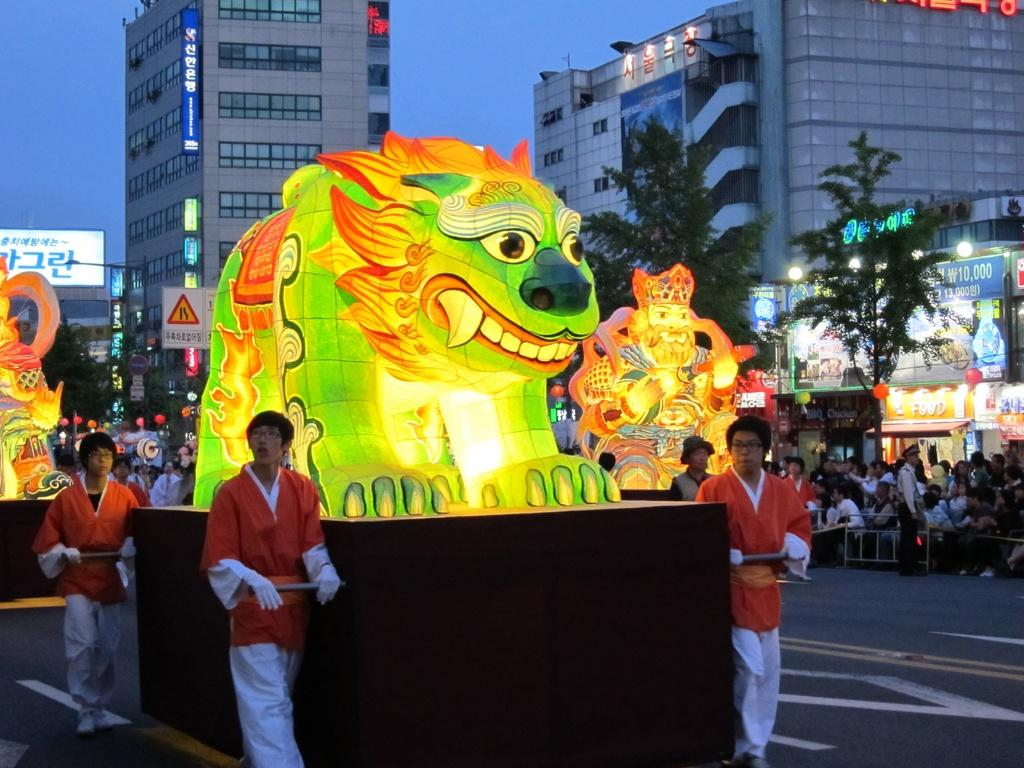What type of objects can be seen in the image? There are colorful objects in the image. Can you describe the people in the image? There are people in the image, and some of them are holding rods. What is the setting of the image? The image features a road, and the background includes banners, trees, buildings, lights, boards, and the sky. Can you tell me how many times the people in the image bite the colorful objects? There is no indication in the image that the people are biting any objects. What type of sink is visible in the background of the image? There is no sink present in the image; the background features banners, trees, buildings, lights, boards, and the sky. 